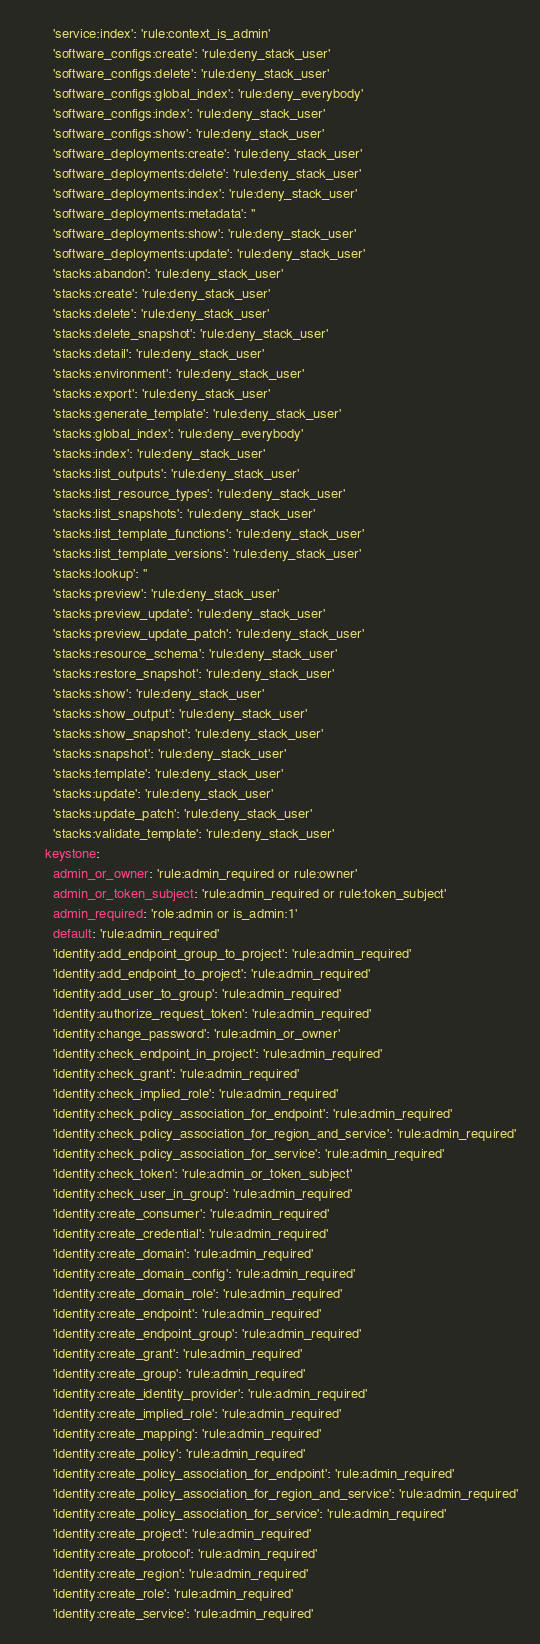Convert code to text. <code><loc_0><loc_0><loc_500><loc_500><_YAML_>        'service:index': 'rule:context_is_admin'
        'software_configs:create': 'rule:deny_stack_user'
        'software_configs:delete': 'rule:deny_stack_user'
        'software_configs:global_index': 'rule:deny_everybody'
        'software_configs:index': 'rule:deny_stack_user'
        'software_configs:show': 'rule:deny_stack_user'
        'software_deployments:create': 'rule:deny_stack_user'
        'software_deployments:delete': 'rule:deny_stack_user'
        'software_deployments:index': 'rule:deny_stack_user'
        'software_deployments:metadata': ''
        'software_deployments:show': 'rule:deny_stack_user'
        'software_deployments:update': 'rule:deny_stack_user'
        'stacks:abandon': 'rule:deny_stack_user'
        'stacks:create': 'rule:deny_stack_user'
        'stacks:delete': 'rule:deny_stack_user'
        'stacks:delete_snapshot': 'rule:deny_stack_user'
        'stacks:detail': 'rule:deny_stack_user'
        'stacks:environment': 'rule:deny_stack_user'
        'stacks:export': 'rule:deny_stack_user'
        'stacks:generate_template': 'rule:deny_stack_user'
        'stacks:global_index': 'rule:deny_everybody'
        'stacks:index': 'rule:deny_stack_user'
        'stacks:list_outputs': 'rule:deny_stack_user'
        'stacks:list_resource_types': 'rule:deny_stack_user'
        'stacks:list_snapshots': 'rule:deny_stack_user'
        'stacks:list_template_functions': 'rule:deny_stack_user'
        'stacks:list_template_versions': 'rule:deny_stack_user'
        'stacks:lookup': ''
        'stacks:preview': 'rule:deny_stack_user'
        'stacks:preview_update': 'rule:deny_stack_user'
        'stacks:preview_update_patch': 'rule:deny_stack_user'
        'stacks:resource_schema': 'rule:deny_stack_user'
        'stacks:restore_snapshot': 'rule:deny_stack_user'
        'stacks:show': 'rule:deny_stack_user'
        'stacks:show_output': 'rule:deny_stack_user'
        'stacks:show_snapshot': 'rule:deny_stack_user'
        'stacks:snapshot': 'rule:deny_stack_user'
        'stacks:template': 'rule:deny_stack_user'
        'stacks:update': 'rule:deny_stack_user'
        'stacks:update_patch': 'rule:deny_stack_user'
        'stacks:validate_template': 'rule:deny_stack_user'
      keystone:
        admin_or_owner: 'rule:admin_required or rule:owner'
        admin_or_token_subject: 'rule:admin_required or rule:token_subject'
        admin_required: 'role:admin or is_admin:1'
        default: 'rule:admin_required'
        'identity:add_endpoint_group_to_project': 'rule:admin_required'
        'identity:add_endpoint_to_project': 'rule:admin_required'
        'identity:add_user_to_group': 'rule:admin_required'
        'identity:authorize_request_token': 'rule:admin_required'
        'identity:change_password': 'rule:admin_or_owner'
        'identity:check_endpoint_in_project': 'rule:admin_required'
        'identity:check_grant': 'rule:admin_required'
        'identity:check_implied_role': 'rule:admin_required'
        'identity:check_policy_association_for_endpoint': 'rule:admin_required'
        'identity:check_policy_association_for_region_and_service': 'rule:admin_required'
        'identity:check_policy_association_for_service': 'rule:admin_required'
        'identity:check_token': 'rule:admin_or_token_subject'
        'identity:check_user_in_group': 'rule:admin_required'
        'identity:create_consumer': 'rule:admin_required'
        'identity:create_credential': 'rule:admin_required'
        'identity:create_domain': 'rule:admin_required'
        'identity:create_domain_config': 'rule:admin_required'
        'identity:create_domain_role': 'rule:admin_required'
        'identity:create_endpoint': 'rule:admin_required'
        'identity:create_endpoint_group': 'rule:admin_required'
        'identity:create_grant': 'rule:admin_required'
        'identity:create_group': 'rule:admin_required'
        'identity:create_identity_provider': 'rule:admin_required'
        'identity:create_implied_role': 'rule:admin_required'
        'identity:create_mapping': 'rule:admin_required'
        'identity:create_policy': 'rule:admin_required'
        'identity:create_policy_association_for_endpoint': 'rule:admin_required'
        'identity:create_policy_association_for_region_and_service': 'rule:admin_required'
        'identity:create_policy_association_for_service': 'rule:admin_required'
        'identity:create_project': 'rule:admin_required'
        'identity:create_protocol': 'rule:admin_required'
        'identity:create_region': 'rule:admin_required'
        'identity:create_role': 'rule:admin_required'
        'identity:create_service': 'rule:admin_required'</code> 